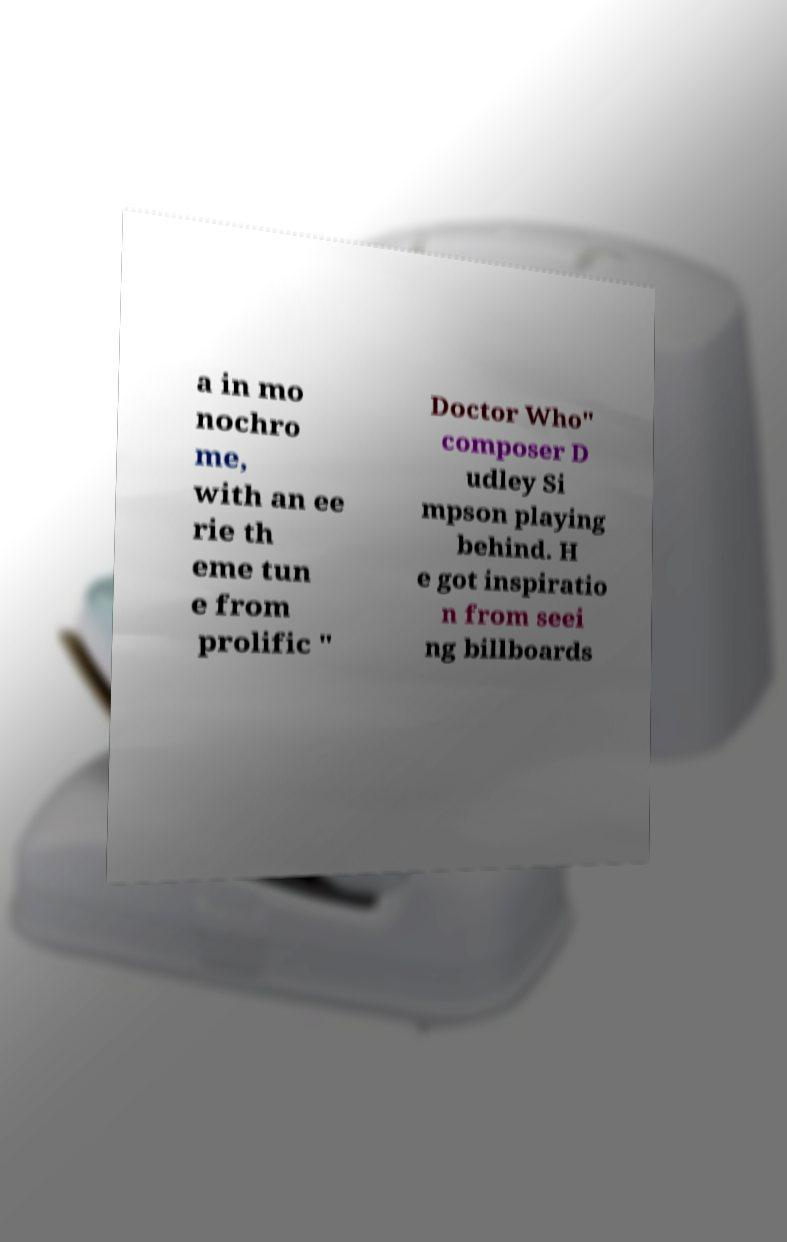What messages or text are displayed in this image? I need them in a readable, typed format. a in mo nochro me, with an ee rie th eme tun e from prolific " Doctor Who" composer D udley Si mpson playing behind. H e got inspiratio n from seei ng billboards 